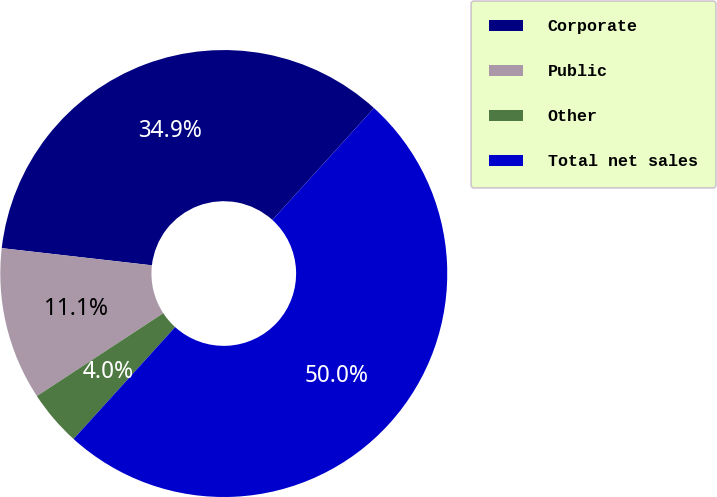<chart> <loc_0><loc_0><loc_500><loc_500><pie_chart><fcel>Corporate<fcel>Public<fcel>Other<fcel>Total net sales<nl><fcel>34.92%<fcel>11.05%<fcel>4.03%<fcel>50.0%<nl></chart> 